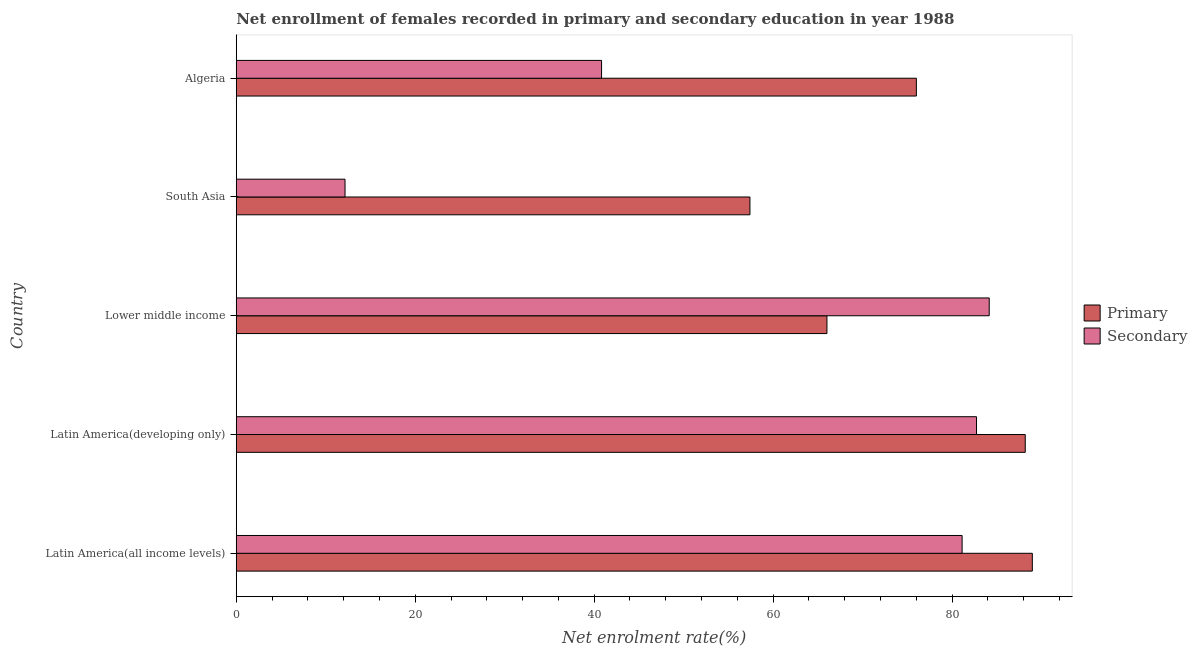Are the number of bars on each tick of the Y-axis equal?
Provide a succinct answer. Yes. How many bars are there on the 4th tick from the bottom?
Offer a terse response. 2. What is the label of the 2nd group of bars from the top?
Your answer should be compact. South Asia. What is the enrollment rate in secondary education in Algeria?
Provide a succinct answer. 40.83. Across all countries, what is the maximum enrollment rate in secondary education?
Provide a succinct answer. 84.15. Across all countries, what is the minimum enrollment rate in secondary education?
Your response must be concise. 12.16. In which country was the enrollment rate in primary education maximum?
Your answer should be compact. Latin America(all income levels). What is the total enrollment rate in primary education in the graph?
Provide a succinct answer. 376.59. What is the difference between the enrollment rate in secondary education in Algeria and that in Latin America(developing only)?
Your answer should be very brief. -41.91. What is the difference between the enrollment rate in secondary education in South Asia and the enrollment rate in primary education in Lower middle income?
Offer a very short reply. -53.86. What is the average enrollment rate in secondary education per country?
Your response must be concise. 60.2. What is the difference between the enrollment rate in primary education and enrollment rate in secondary education in Latin America(all income levels)?
Offer a terse response. 7.85. In how many countries, is the enrollment rate in secondary education greater than 4 %?
Offer a terse response. 5. What is the ratio of the enrollment rate in secondary education in Algeria to that in Latin America(all income levels)?
Provide a succinct answer. 0.5. Is the enrollment rate in secondary education in Latin America(all income levels) less than that in South Asia?
Provide a short and direct response. No. What is the difference between the highest and the second highest enrollment rate in secondary education?
Ensure brevity in your answer.  1.42. What is the difference between the highest and the lowest enrollment rate in secondary education?
Give a very brief answer. 71.99. Is the sum of the enrollment rate in secondary education in Algeria and South Asia greater than the maximum enrollment rate in primary education across all countries?
Provide a short and direct response. No. What does the 2nd bar from the top in South Asia represents?
Provide a short and direct response. Primary. What does the 2nd bar from the bottom in Algeria represents?
Offer a terse response. Secondary. Are all the bars in the graph horizontal?
Offer a terse response. Yes. Does the graph contain any zero values?
Your answer should be very brief. No. Does the graph contain grids?
Keep it short and to the point. No. What is the title of the graph?
Provide a succinct answer. Net enrollment of females recorded in primary and secondary education in year 1988. Does "GDP at market prices" appear as one of the legend labels in the graph?
Your answer should be compact. No. What is the label or title of the X-axis?
Offer a very short reply. Net enrolment rate(%). What is the Net enrolment rate(%) in Primary in Latin America(all income levels)?
Your response must be concise. 88.97. What is the Net enrolment rate(%) in Secondary in Latin America(all income levels)?
Offer a terse response. 81.12. What is the Net enrolment rate(%) of Primary in Latin America(developing only)?
Offer a terse response. 88.18. What is the Net enrolment rate(%) of Secondary in Latin America(developing only)?
Offer a very short reply. 82.73. What is the Net enrolment rate(%) in Primary in Lower middle income?
Your answer should be compact. 66.02. What is the Net enrolment rate(%) of Secondary in Lower middle income?
Offer a very short reply. 84.15. What is the Net enrolment rate(%) of Primary in South Asia?
Your answer should be very brief. 57.41. What is the Net enrolment rate(%) of Secondary in South Asia?
Keep it short and to the point. 12.16. What is the Net enrolment rate(%) of Primary in Algeria?
Give a very brief answer. 76.01. What is the Net enrolment rate(%) in Secondary in Algeria?
Offer a terse response. 40.83. Across all countries, what is the maximum Net enrolment rate(%) of Primary?
Provide a short and direct response. 88.97. Across all countries, what is the maximum Net enrolment rate(%) in Secondary?
Provide a succinct answer. 84.15. Across all countries, what is the minimum Net enrolment rate(%) of Primary?
Make the answer very short. 57.41. Across all countries, what is the minimum Net enrolment rate(%) of Secondary?
Ensure brevity in your answer.  12.16. What is the total Net enrolment rate(%) of Primary in the graph?
Keep it short and to the point. 376.59. What is the total Net enrolment rate(%) in Secondary in the graph?
Your response must be concise. 300.99. What is the difference between the Net enrolment rate(%) of Primary in Latin America(all income levels) and that in Latin America(developing only)?
Your response must be concise. 0.79. What is the difference between the Net enrolment rate(%) of Secondary in Latin America(all income levels) and that in Latin America(developing only)?
Offer a terse response. -1.61. What is the difference between the Net enrolment rate(%) in Primary in Latin America(all income levels) and that in Lower middle income?
Your answer should be compact. 22.95. What is the difference between the Net enrolment rate(%) in Secondary in Latin America(all income levels) and that in Lower middle income?
Your response must be concise. -3.03. What is the difference between the Net enrolment rate(%) of Primary in Latin America(all income levels) and that in South Asia?
Your answer should be compact. 31.56. What is the difference between the Net enrolment rate(%) in Secondary in Latin America(all income levels) and that in South Asia?
Your response must be concise. 68.96. What is the difference between the Net enrolment rate(%) of Primary in Latin America(all income levels) and that in Algeria?
Your answer should be very brief. 12.96. What is the difference between the Net enrolment rate(%) in Secondary in Latin America(all income levels) and that in Algeria?
Make the answer very short. 40.3. What is the difference between the Net enrolment rate(%) in Primary in Latin America(developing only) and that in Lower middle income?
Ensure brevity in your answer.  22.16. What is the difference between the Net enrolment rate(%) of Secondary in Latin America(developing only) and that in Lower middle income?
Make the answer very short. -1.42. What is the difference between the Net enrolment rate(%) in Primary in Latin America(developing only) and that in South Asia?
Your answer should be compact. 30.77. What is the difference between the Net enrolment rate(%) in Secondary in Latin America(developing only) and that in South Asia?
Provide a succinct answer. 70.57. What is the difference between the Net enrolment rate(%) in Primary in Latin America(developing only) and that in Algeria?
Offer a very short reply. 12.17. What is the difference between the Net enrolment rate(%) of Secondary in Latin America(developing only) and that in Algeria?
Ensure brevity in your answer.  41.91. What is the difference between the Net enrolment rate(%) of Primary in Lower middle income and that in South Asia?
Offer a very short reply. 8.61. What is the difference between the Net enrolment rate(%) in Secondary in Lower middle income and that in South Asia?
Your response must be concise. 71.99. What is the difference between the Net enrolment rate(%) of Primary in Lower middle income and that in Algeria?
Your response must be concise. -10. What is the difference between the Net enrolment rate(%) of Secondary in Lower middle income and that in Algeria?
Keep it short and to the point. 43.33. What is the difference between the Net enrolment rate(%) of Primary in South Asia and that in Algeria?
Your answer should be compact. -18.6. What is the difference between the Net enrolment rate(%) of Secondary in South Asia and that in Algeria?
Your answer should be very brief. -28.67. What is the difference between the Net enrolment rate(%) of Primary in Latin America(all income levels) and the Net enrolment rate(%) of Secondary in Latin America(developing only)?
Keep it short and to the point. 6.24. What is the difference between the Net enrolment rate(%) of Primary in Latin America(all income levels) and the Net enrolment rate(%) of Secondary in Lower middle income?
Provide a short and direct response. 4.82. What is the difference between the Net enrolment rate(%) of Primary in Latin America(all income levels) and the Net enrolment rate(%) of Secondary in South Asia?
Ensure brevity in your answer.  76.81. What is the difference between the Net enrolment rate(%) in Primary in Latin America(all income levels) and the Net enrolment rate(%) in Secondary in Algeria?
Offer a very short reply. 48.14. What is the difference between the Net enrolment rate(%) in Primary in Latin America(developing only) and the Net enrolment rate(%) in Secondary in Lower middle income?
Offer a very short reply. 4.03. What is the difference between the Net enrolment rate(%) of Primary in Latin America(developing only) and the Net enrolment rate(%) of Secondary in South Asia?
Ensure brevity in your answer.  76.02. What is the difference between the Net enrolment rate(%) in Primary in Latin America(developing only) and the Net enrolment rate(%) in Secondary in Algeria?
Make the answer very short. 47.35. What is the difference between the Net enrolment rate(%) of Primary in Lower middle income and the Net enrolment rate(%) of Secondary in South Asia?
Offer a terse response. 53.86. What is the difference between the Net enrolment rate(%) of Primary in Lower middle income and the Net enrolment rate(%) of Secondary in Algeria?
Your answer should be very brief. 25.19. What is the difference between the Net enrolment rate(%) of Primary in South Asia and the Net enrolment rate(%) of Secondary in Algeria?
Make the answer very short. 16.58. What is the average Net enrolment rate(%) in Primary per country?
Ensure brevity in your answer.  75.32. What is the average Net enrolment rate(%) of Secondary per country?
Make the answer very short. 60.2. What is the difference between the Net enrolment rate(%) in Primary and Net enrolment rate(%) in Secondary in Latin America(all income levels)?
Give a very brief answer. 7.85. What is the difference between the Net enrolment rate(%) in Primary and Net enrolment rate(%) in Secondary in Latin America(developing only)?
Keep it short and to the point. 5.45. What is the difference between the Net enrolment rate(%) of Primary and Net enrolment rate(%) of Secondary in Lower middle income?
Provide a succinct answer. -18.14. What is the difference between the Net enrolment rate(%) of Primary and Net enrolment rate(%) of Secondary in South Asia?
Your answer should be compact. 45.25. What is the difference between the Net enrolment rate(%) in Primary and Net enrolment rate(%) in Secondary in Algeria?
Your answer should be compact. 35.18. What is the ratio of the Net enrolment rate(%) in Secondary in Latin America(all income levels) to that in Latin America(developing only)?
Give a very brief answer. 0.98. What is the ratio of the Net enrolment rate(%) in Primary in Latin America(all income levels) to that in Lower middle income?
Ensure brevity in your answer.  1.35. What is the ratio of the Net enrolment rate(%) in Secondary in Latin America(all income levels) to that in Lower middle income?
Make the answer very short. 0.96. What is the ratio of the Net enrolment rate(%) in Primary in Latin America(all income levels) to that in South Asia?
Offer a very short reply. 1.55. What is the ratio of the Net enrolment rate(%) of Secondary in Latin America(all income levels) to that in South Asia?
Provide a succinct answer. 6.67. What is the ratio of the Net enrolment rate(%) of Primary in Latin America(all income levels) to that in Algeria?
Give a very brief answer. 1.17. What is the ratio of the Net enrolment rate(%) in Secondary in Latin America(all income levels) to that in Algeria?
Provide a short and direct response. 1.99. What is the ratio of the Net enrolment rate(%) of Primary in Latin America(developing only) to that in Lower middle income?
Your answer should be very brief. 1.34. What is the ratio of the Net enrolment rate(%) of Secondary in Latin America(developing only) to that in Lower middle income?
Offer a very short reply. 0.98. What is the ratio of the Net enrolment rate(%) of Primary in Latin America(developing only) to that in South Asia?
Offer a very short reply. 1.54. What is the ratio of the Net enrolment rate(%) of Secondary in Latin America(developing only) to that in South Asia?
Offer a very short reply. 6.8. What is the ratio of the Net enrolment rate(%) of Primary in Latin America(developing only) to that in Algeria?
Keep it short and to the point. 1.16. What is the ratio of the Net enrolment rate(%) in Secondary in Latin America(developing only) to that in Algeria?
Provide a short and direct response. 2.03. What is the ratio of the Net enrolment rate(%) in Primary in Lower middle income to that in South Asia?
Ensure brevity in your answer.  1.15. What is the ratio of the Net enrolment rate(%) of Secondary in Lower middle income to that in South Asia?
Keep it short and to the point. 6.92. What is the ratio of the Net enrolment rate(%) of Primary in Lower middle income to that in Algeria?
Your answer should be compact. 0.87. What is the ratio of the Net enrolment rate(%) of Secondary in Lower middle income to that in Algeria?
Give a very brief answer. 2.06. What is the ratio of the Net enrolment rate(%) in Primary in South Asia to that in Algeria?
Make the answer very short. 0.76. What is the ratio of the Net enrolment rate(%) in Secondary in South Asia to that in Algeria?
Keep it short and to the point. 0.3. What is the difference between the highest and the second highest Net enrolment rate(%) of Primary?
Make the answer very short. 0.79. What is the difference between the highest and the second highest Net enrolment rate(%) in Secondary?
Give a very brief answer. 1.42. What is the difference between the highest and the lowest Net enrolment rate(%) of Primary?
Make the answer very short. 31.56. What is the difference between the highest and the lowest Net enrolment rate(%) of Secondary?
Offer a very short reply. 71.99. 